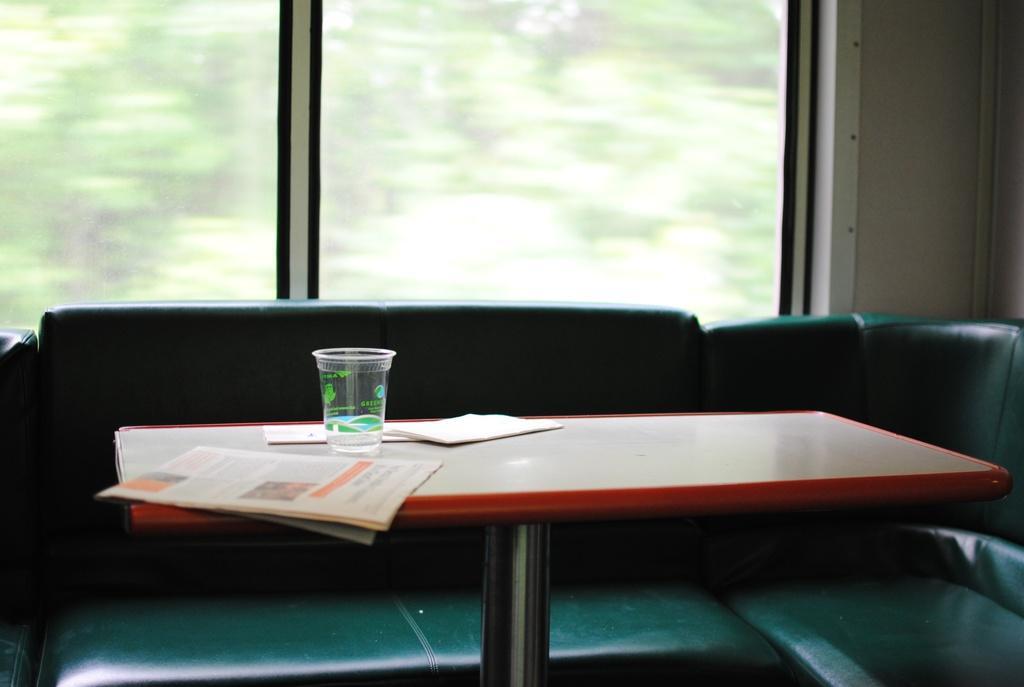Can you describe this image briefly? In the image there is a table with newspapers and a glass. Behind the table there is a sofa. Behind the sofa there are glass windows. 